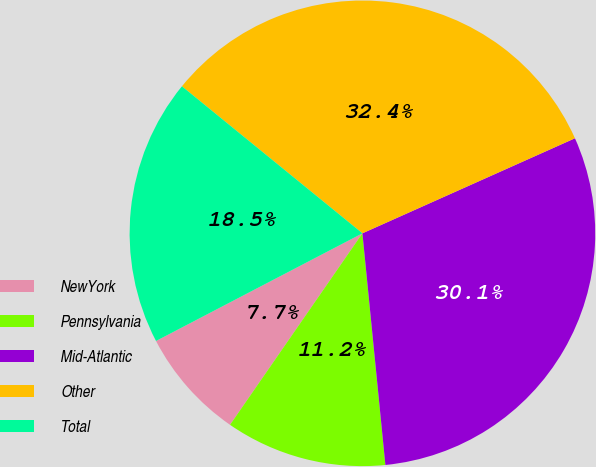<chart> <loc_0><loc_0><loc_500><loc_500><pie_chart><fcel>NewYork<fcel>Pennsylvania<fcel>Mid-Atlantic<fcel>Other<fcel>Total<nl><fcel>7.72%<fcel>11.2%<fcel>30.12%<fcel>32.43%<fcel>18.53%<nl></chart> 